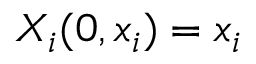Convert formula to latex. <formula><loc_0><loc_0><loc_500><loc_500>X _ { i } ( 0 , x _ { i } ) = x _ { i }</formula> 